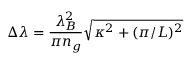Convert formula to latex. <formula><loc_0><loc_0><loc_500><loc_500>\Delta \lambda = \frac { \lambda _ { B } ^ { 2 } } { \pi n _ { g } } \sqrt { \kappa ^ { 2 } + ( \pi / L ) ^ { 2 } }</formula> 